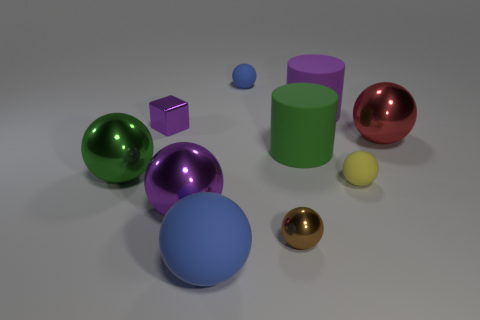How many big things are to the left of the large matte thing in front of the big green metal thing behind the brown metal object?
Keep it short and to the point. 2. The small shiny ball is what color?
Your answer should be very brief. Brown. What number of other objects are the same size as the red shiny sphere?
Give a very brief answer. 5. There is a tiny brown object that is the same shape as the tiny blue thing; what is its material?
Your answer should be compact. Metal. The large sphere that is on the right side of the small object that is behind the purple object to the right of the brown ball is made of what material?
Your response must be concise. Metal. There is another cylinder that is the same material as the purple cylinder; what is its size?
Your response must be concise. Large. Are there any other things that have the same color as the block?
Offer a very short reply. Yes. There is a tiny object that is in front of the big purple shiny thing; is its color the same as the block that is in front of the purple cylinder?
Your answer should be very brief. No. What is the color of the big metal object to the right of the tiny blue matte ball?
Provide a succinct answer. Red. Does the blue matte object that is in front of the metal block have the same size as the red thing?
Keep it short and to the point. Yes. 